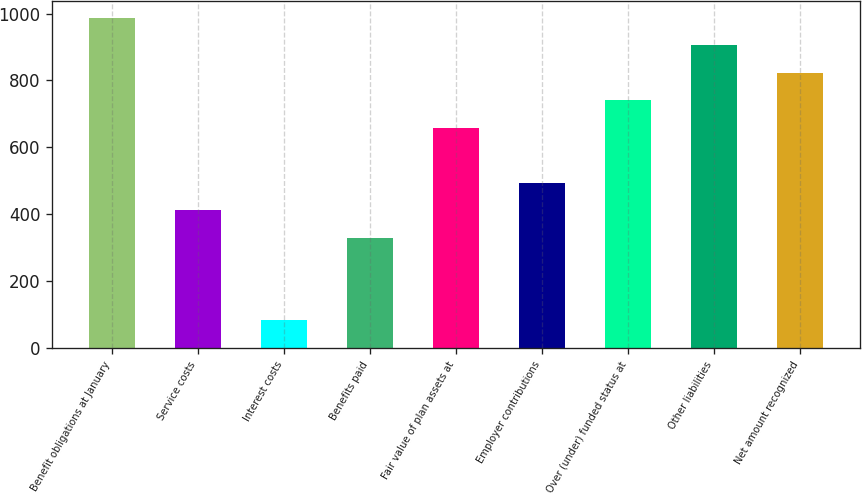Convert chart. <chart><loc_0><loc_0><loc_500><loc_500><bar_chart><fcel>Benefit obligations at January<fcel>Service costs<fcel>Interest costs<fcel>Benefits paid<fcel>Fair value of plan assets at<fcel>Employer contributions<fcel>Over (under) funded status at<fcel>Other liabilities<fcel>Net amount recognized<nl><fcel>987.2<fcel>412.5<fcel>84.1<fcel>330.4<fcel>658.8<fcel>494.6<fcel>740.9<fcel>905.1<fcel>823<nl></chart> 